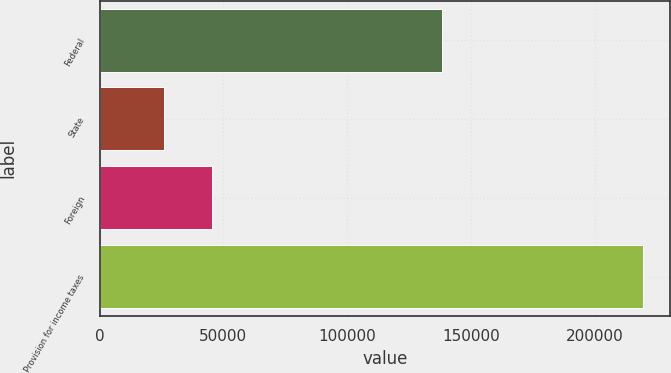Convert chart to OTSL. <chart><loc_0><loc_0><loc_500><loc_500><bar_chart><fcel>Federal<fcel>State<fcel>Foreign<fcel>Provision for income taxes<nl><fcel>138432<fcel>25952<fcel>45327.1<fcel>219703<nl></chart> 